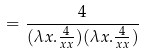Convert formula to latex. <formula><loc_0><loc_0><loc_500><loc_500>= \frac { 4 } { ( \lambda x . \frac { 4 } { x x } ) ( \lambda x . \frac { 4 } { x x } ) }</formula> 